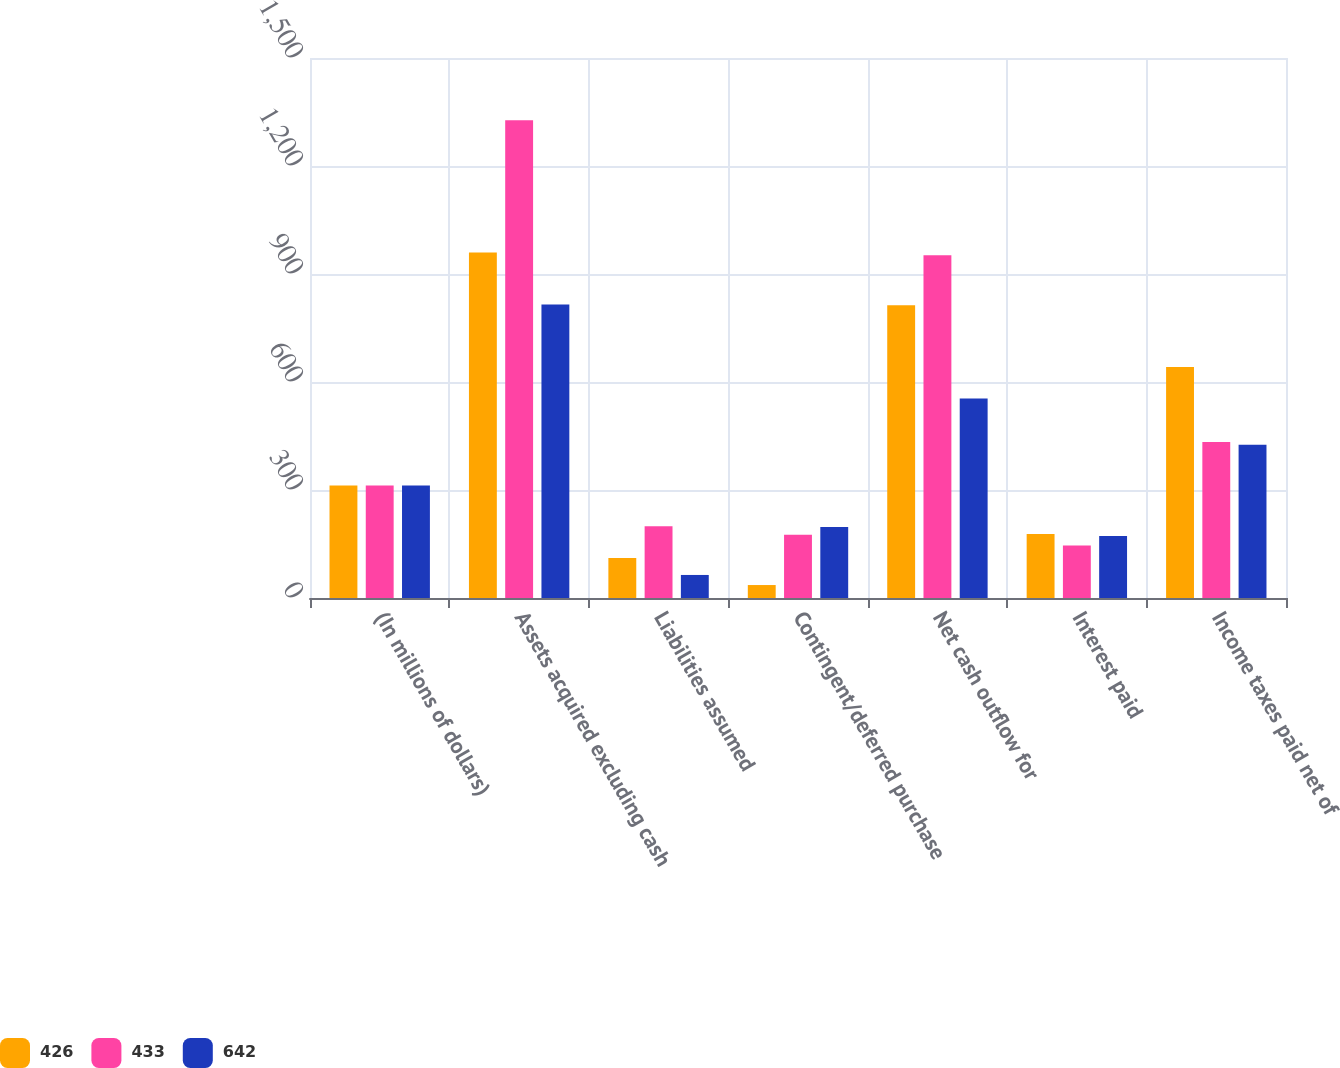<chart> <loc_0><loc_0><loc_500><loc_500><stacked_bar_chart><ecel><fcel>(In millions of dollars)<fcel>Assets acquired excluding cash<fcel>Liabilities assumed<fcel>Contingent/deferred purchase<fcel>Net cash outflow for<fcel>Interest paid<fcel>Income taxes paid net of<nl><fcel>426<fcel>312.5<fcel>960<fcel>111<fcel>36<fcel>813<fcel>178<fcel>642<nl><fcel>433<fcel>312.5<fcel>1327<fcel>199<fcel>176<fcel>952<fcel>146<fcel>433<nl><fcel>642<fcel>312.5<fcel>815<fcel>64<fcel>197<fcel>554<fcel>172<fcel>426<nl></chart> 